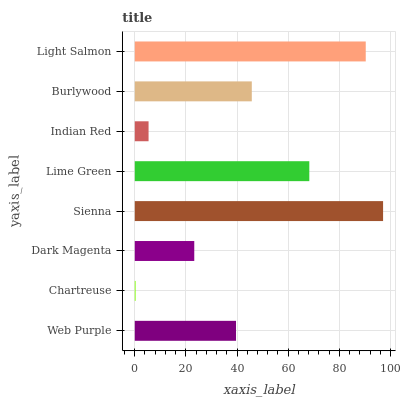Is Chartreuse the minimum?
Answer yes or no. Yes. Is Sienna the maximum?
Answer yes or no. Yes. Is Dark Magenta the minimum?
Answer yes or no. No. Is Dark Magenta the maximum?
Answer yes or no. No. Is Dark Magenta greater than Chartreuse?
Answer yes or no. Yes. Is Chartreuse less than Dark Magenta?
Answer yes or no. Yes. Is Chartreuse greater than Dark Magenta?
Answer yes or no. No. Is Dark Magenta less than Chartreuse?
Answer yes or no. No. Is Burlywood the high median?
Answer yes or no. Yes. Is Web Purple the low median?
Answer yes or no. Yes. Is Light Salmon the high median?
Answer yes or no. No. Is Burlywood the low median?
Answer yes or no. No. 